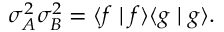Convert formula to latex. <formula><loc_0><loc_0><loc_500><loc_500>\sigma _ { A } ^ { 2 } \sigma _ { B } ^ { 2 } = \langle f | f \rangle \langle g | g \rangle .</formula> 